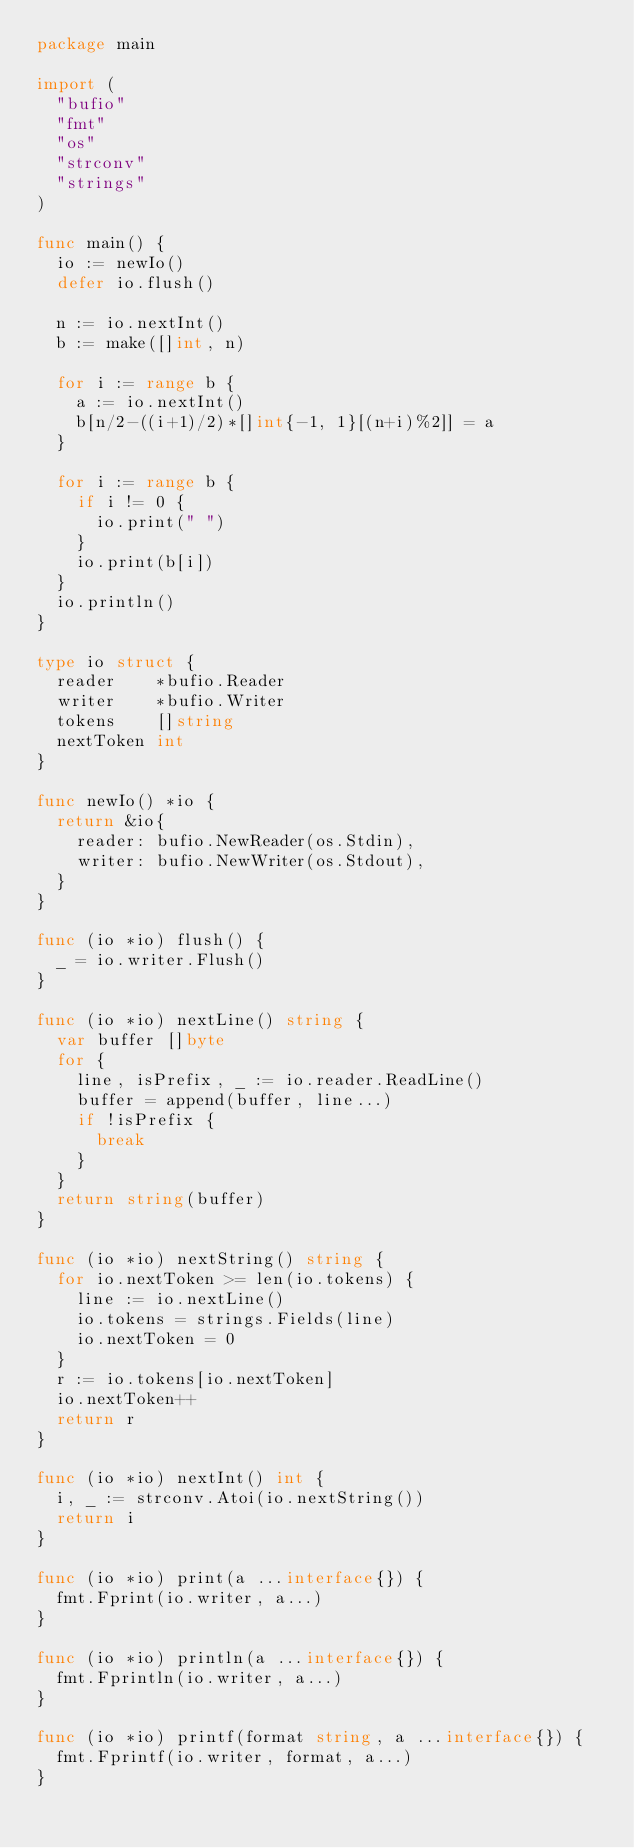<code> <loc_0><loc_0><loc_500><loc_500><_Go_>package main

import (
	"bufio"
	"fmt"
	"os"
	"strconv"
	"strings"
)

func main() {
	io := newIo()
	defer io.flush()

	n := io.nextInt()
	b := make([]int, n)

	for i := range b {
		a := io.nextInt()
		b[n/2-((i+1)/2)*[]int{-1, 1}[(n+i)%2]] = a
	}

	for i := range b {
		if i != 0 {
			io.print(" ")
		}
		io.print(b[i])
	}
	io.println()
}

type io struct {
	reader    *bufio.Reader
	writer    *bufio.Writer
	tokens    []string
	nextToken int
}

func newIo() *io {
	return &io{
		reader: bufio.NewReader(os.Stdin),
		writer: bufio.NewWriter(os.Stdout),
	}
}

func (io *io) flush() {
	_ = io.writer.Flush()
}

func (io *io) nextLine() string {
	var buffer []byte
	for {
		line, isPrefix, _ := io.reader.ReadLine()
		buffer = append(buffer, line...)
		if !isPrefix {
			break
		}
	}
	return string(buffer)
}

func (io *io) nextString() string {
	for io.nextToken >= len(io.tokens) {
		line := io.nextLine()
		io.tokens = strings.Fields(line)
		io.nextToken = 0
	}
	r := io.tokens[io.nextToken]
	io.nextToken++
	return r
}

func (io *io) nextInt() int {
	i, _ := strconv.Atoi(io.nextString())
	return i
}

func (io *io) print(a ...interface{}) {
	fmt.Fprint(io.writer, a...)
}

func (io *io) println(a ...interface{}) {
	fmt.Fprintln(io.writer, a...)
}

func (io *io) printf(format string, a ...interface{}) {
	fmt.Fprintf(io.writer, format, a...)
}
</code> 